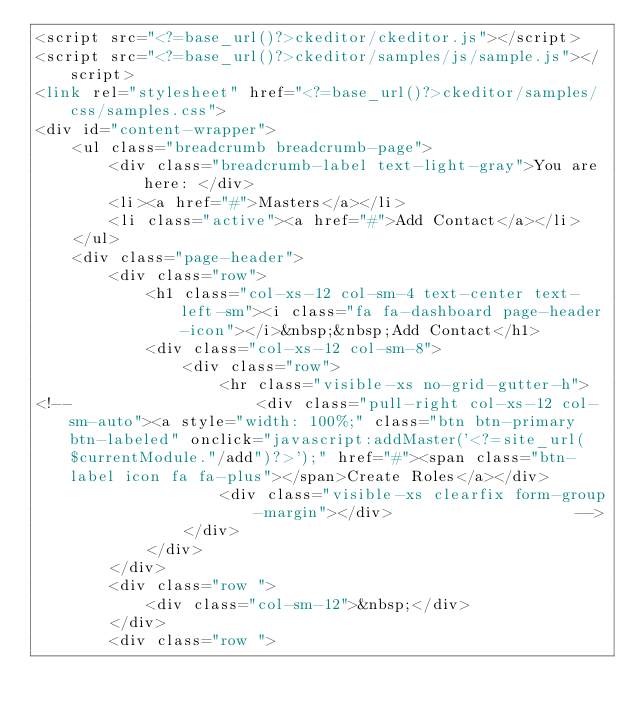Convert code to text. <code><loc_0><loc_0><loc_500><loc_500><_PHP_><script src="<?=base_url()?>ckeditor/ckeditor.js"></script>
<script src="<?=base_url()?>ckeditor/samples/js/sample.js"></script>
<link rel="stylesheet" href="<?=base_url()?>ckeditor/samples/css/samples.css">
<div id="content-wrapper">
    <ul class="breadcrumb breadcrumb-page">
        <div class="breadcrumb-label text-light-gray">You are here: </div>
        <li><a href="#">Masters</a></li>
        <li class="active"><a href="#">Add Contact</a></li>
    </ul>
    <div class="page-header">			
        <div class="row">
            <h1 class="col-xs-12 col-sm-4 text-center text-left-sm"><i class="fa fa-dashboard page-header-icon"></i>&nbsp;&nbsp;Add Contact</h1>
            <div class="col-xs-12 col-sm-8">
                <div class="row">                    
                    <hr class="visible-xs no-grid-gutter-h">
<!--                    <div class="pull-right col-xs-12 col-sm-auto"><a style="width: 100%;" class="btn btn-primary btn-labeled" onclick="javascript:addMaster('<?=site_url($currentModule."/add")?>');" href="#"><span class="btn-label icon fa fa-plus"></span>Create Roles</a></div>                        
                    <div class="visible-xs clearfix form-group-margin"></div>                    -->
                </div>
            </div>
        </div>
        <div class="row ">
            <div class="col-sm-12">&nbsp;</div>
        </div>
        <div class="row "></code> 